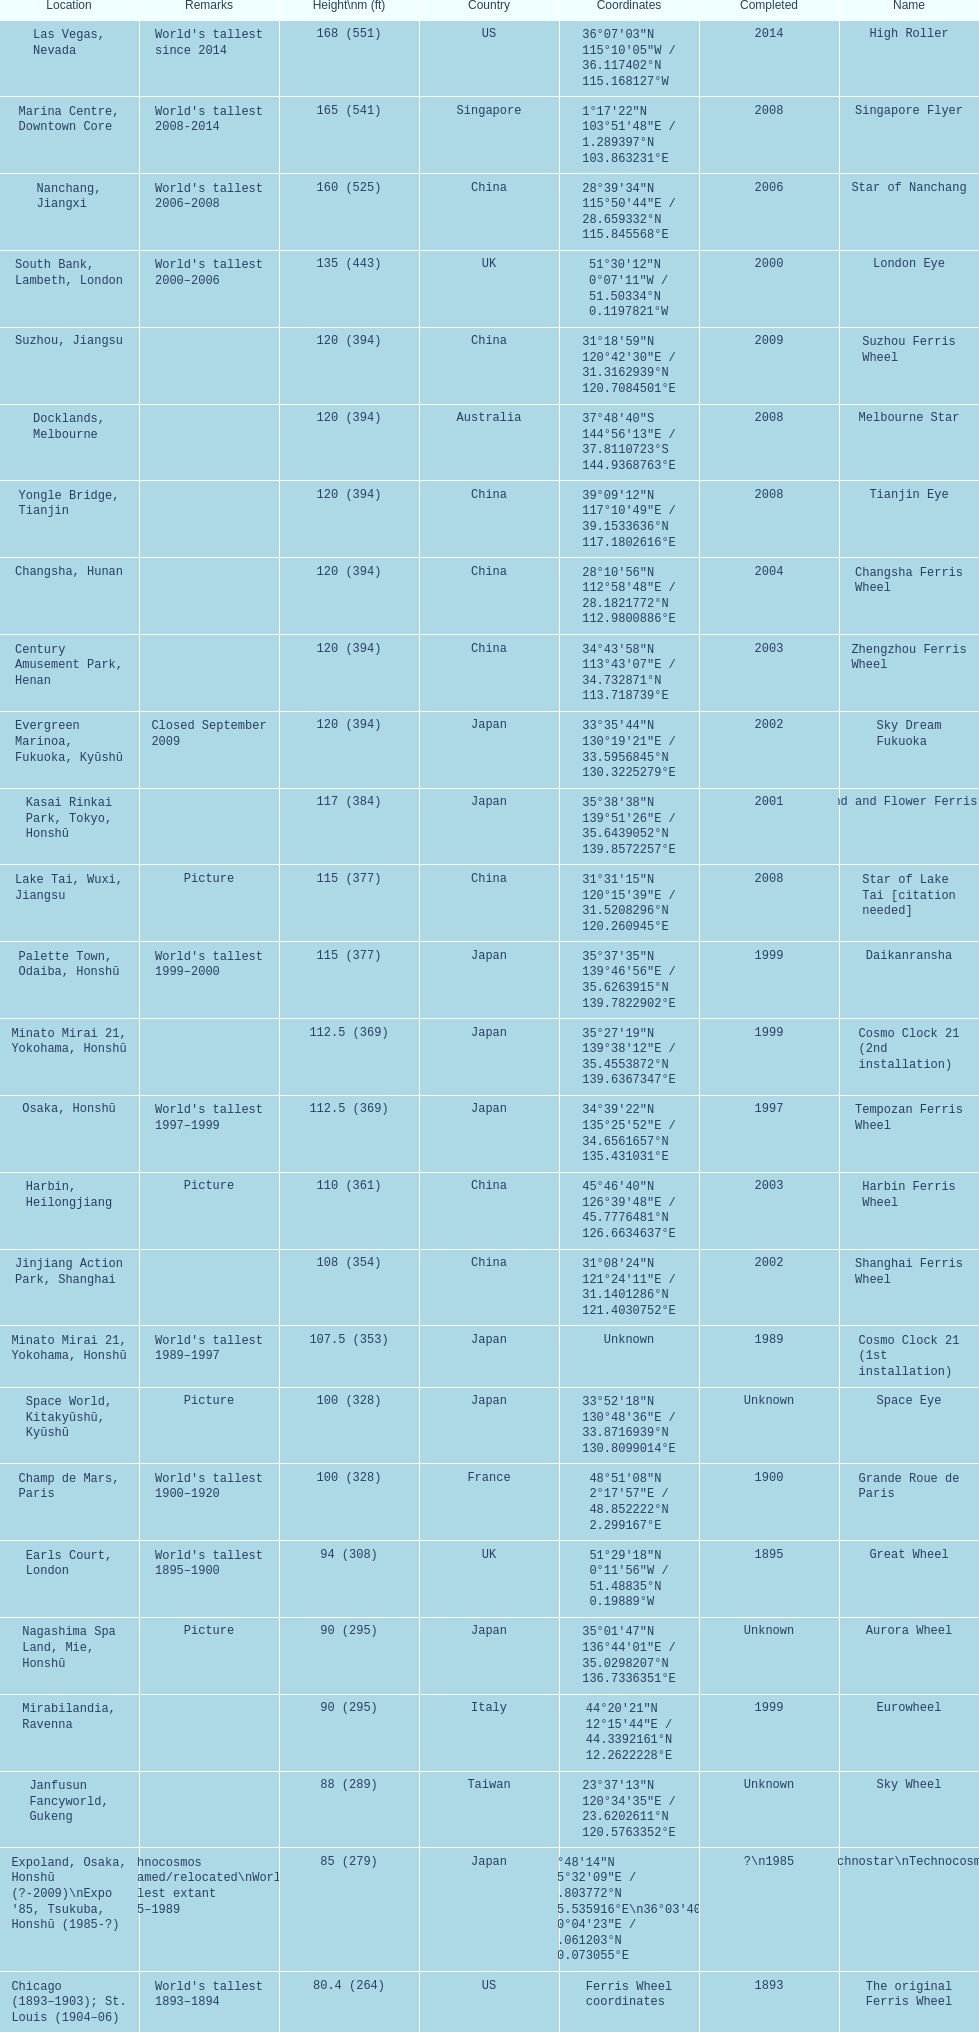What ferris wheels were completed in 2008 Singapore Flyer, Melbourne Star, Tianjin Eye, Star of Lake Tai [citation needed]. Of these, which has the height of 165? Singapore Flyer. 